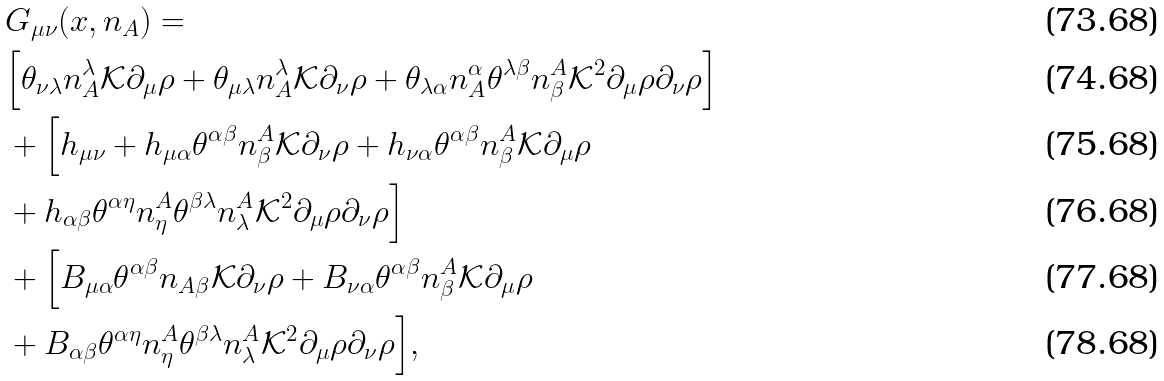<formula> <loc_0><loc_0><loc_500><loc_500>& G _ { \mu \nu } ( x , n _ { A } ) = \\ & \Big { [ } \theta _ { \nu \lambda } n ^ { \lambda } _ { A } \mathcal { K } \partial _ { \mu } \rho + \theta _ { \mu \lambda } n ^ { \lambda } _ { A } \mathcal { K } \partial _ { \nu } \rho + \theta _ { \lambda \alpha } n ^ { \alpha } _ { A } \theta ^ { \lambda \beta } n ^ { A } _ { \beta } \mathcal { K } ^ { 2 } \partial _ { \mu } \rho \partial _ { \nu } \rho \Big { ] } \\ & + \Big { [ } h _ { \mu \nu } + h _ { \mu \alpha } \theta ^ { \alpha \beta } n ^ { A } _ { \beta } \mathcal { K } \partial _ { \nu } \rho + h _ { \nu \alpha } \theta ^ { \alpha \beta } n ^ { A } _ { \beta } \mathcal { K } \partial _ { \mu } \rho \\ & + h _ { \alpha \beta } \theta ^ { \alpha \eta } n ^ { A } _ { \eta } \theta ^ { \beta \lambda } n ^ { A } _ { \lambda } \mathcal { K } ^ { 2 } \partial _ { \mu } \rho \partial _ { \nu } \rho \Big { ] } \\ & + \Big { [ } B _ { \mu \alpha } \theta ^ { \alpha \beta } n _ { A \beta } \mathcal { K } \partial _ { \nu } \rho + B _ { \nu \alpha } \theta ^ { \alpha \beta } n ^ { A } _ { \beta } \mathcal { K } \partial _ { \mu } \rho \\ & + B _ { \alpha \beta } \theta ^ { \alpha \eta } n ^ { A } _ { \eta } \theta ^ { \beta \lambda } n ^ { A } _ { \lambda } \mathcal { K } ^ { 2 } \partial _ { \mu } \rho \partial _ { \nu } \rho \Big { ] } ,</formula> 